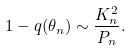<formula> <loc_0><loc_0><loc_500><loc_500>1 - q ( \theta _ { n } ) \sim \frac { K ^ { 2 } _ { n } } { P _ { n } } .</formula> 